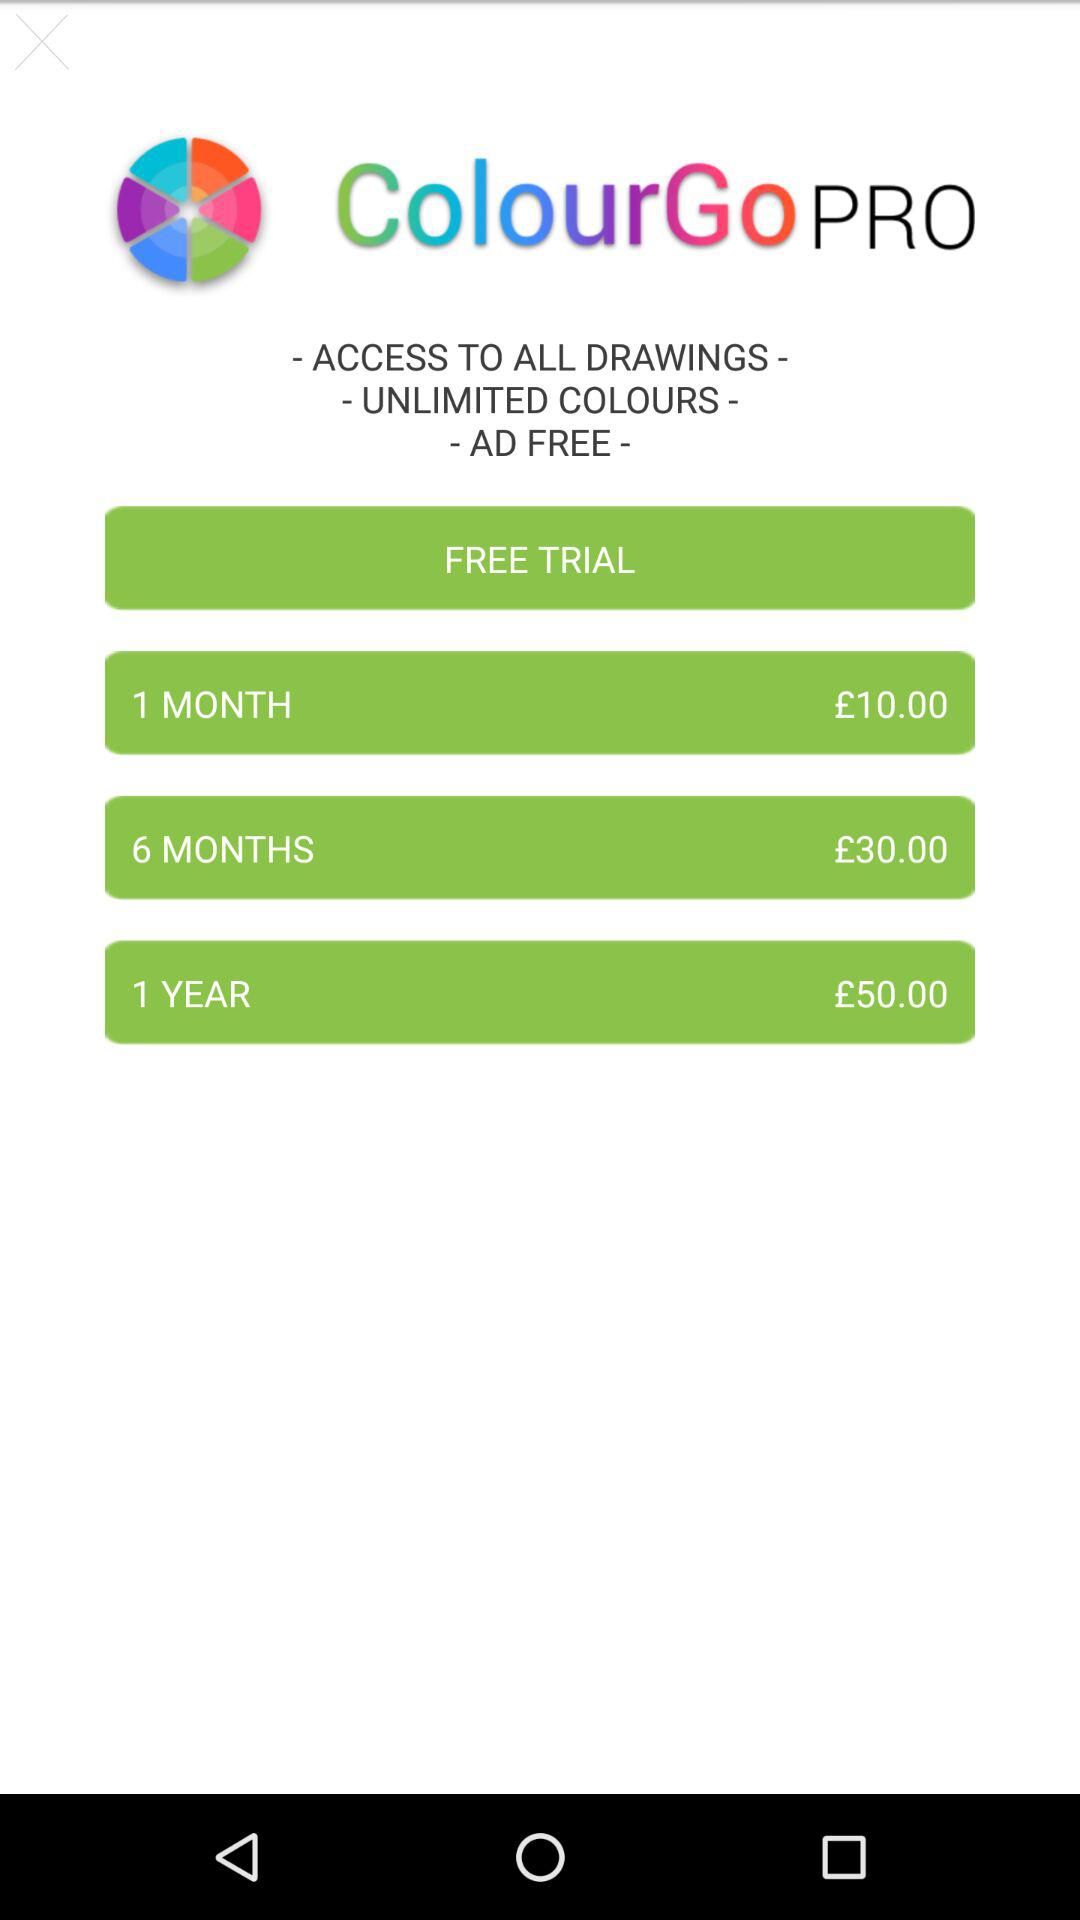What is the fee for 1 year? The fee for 1 year is £50.00. 